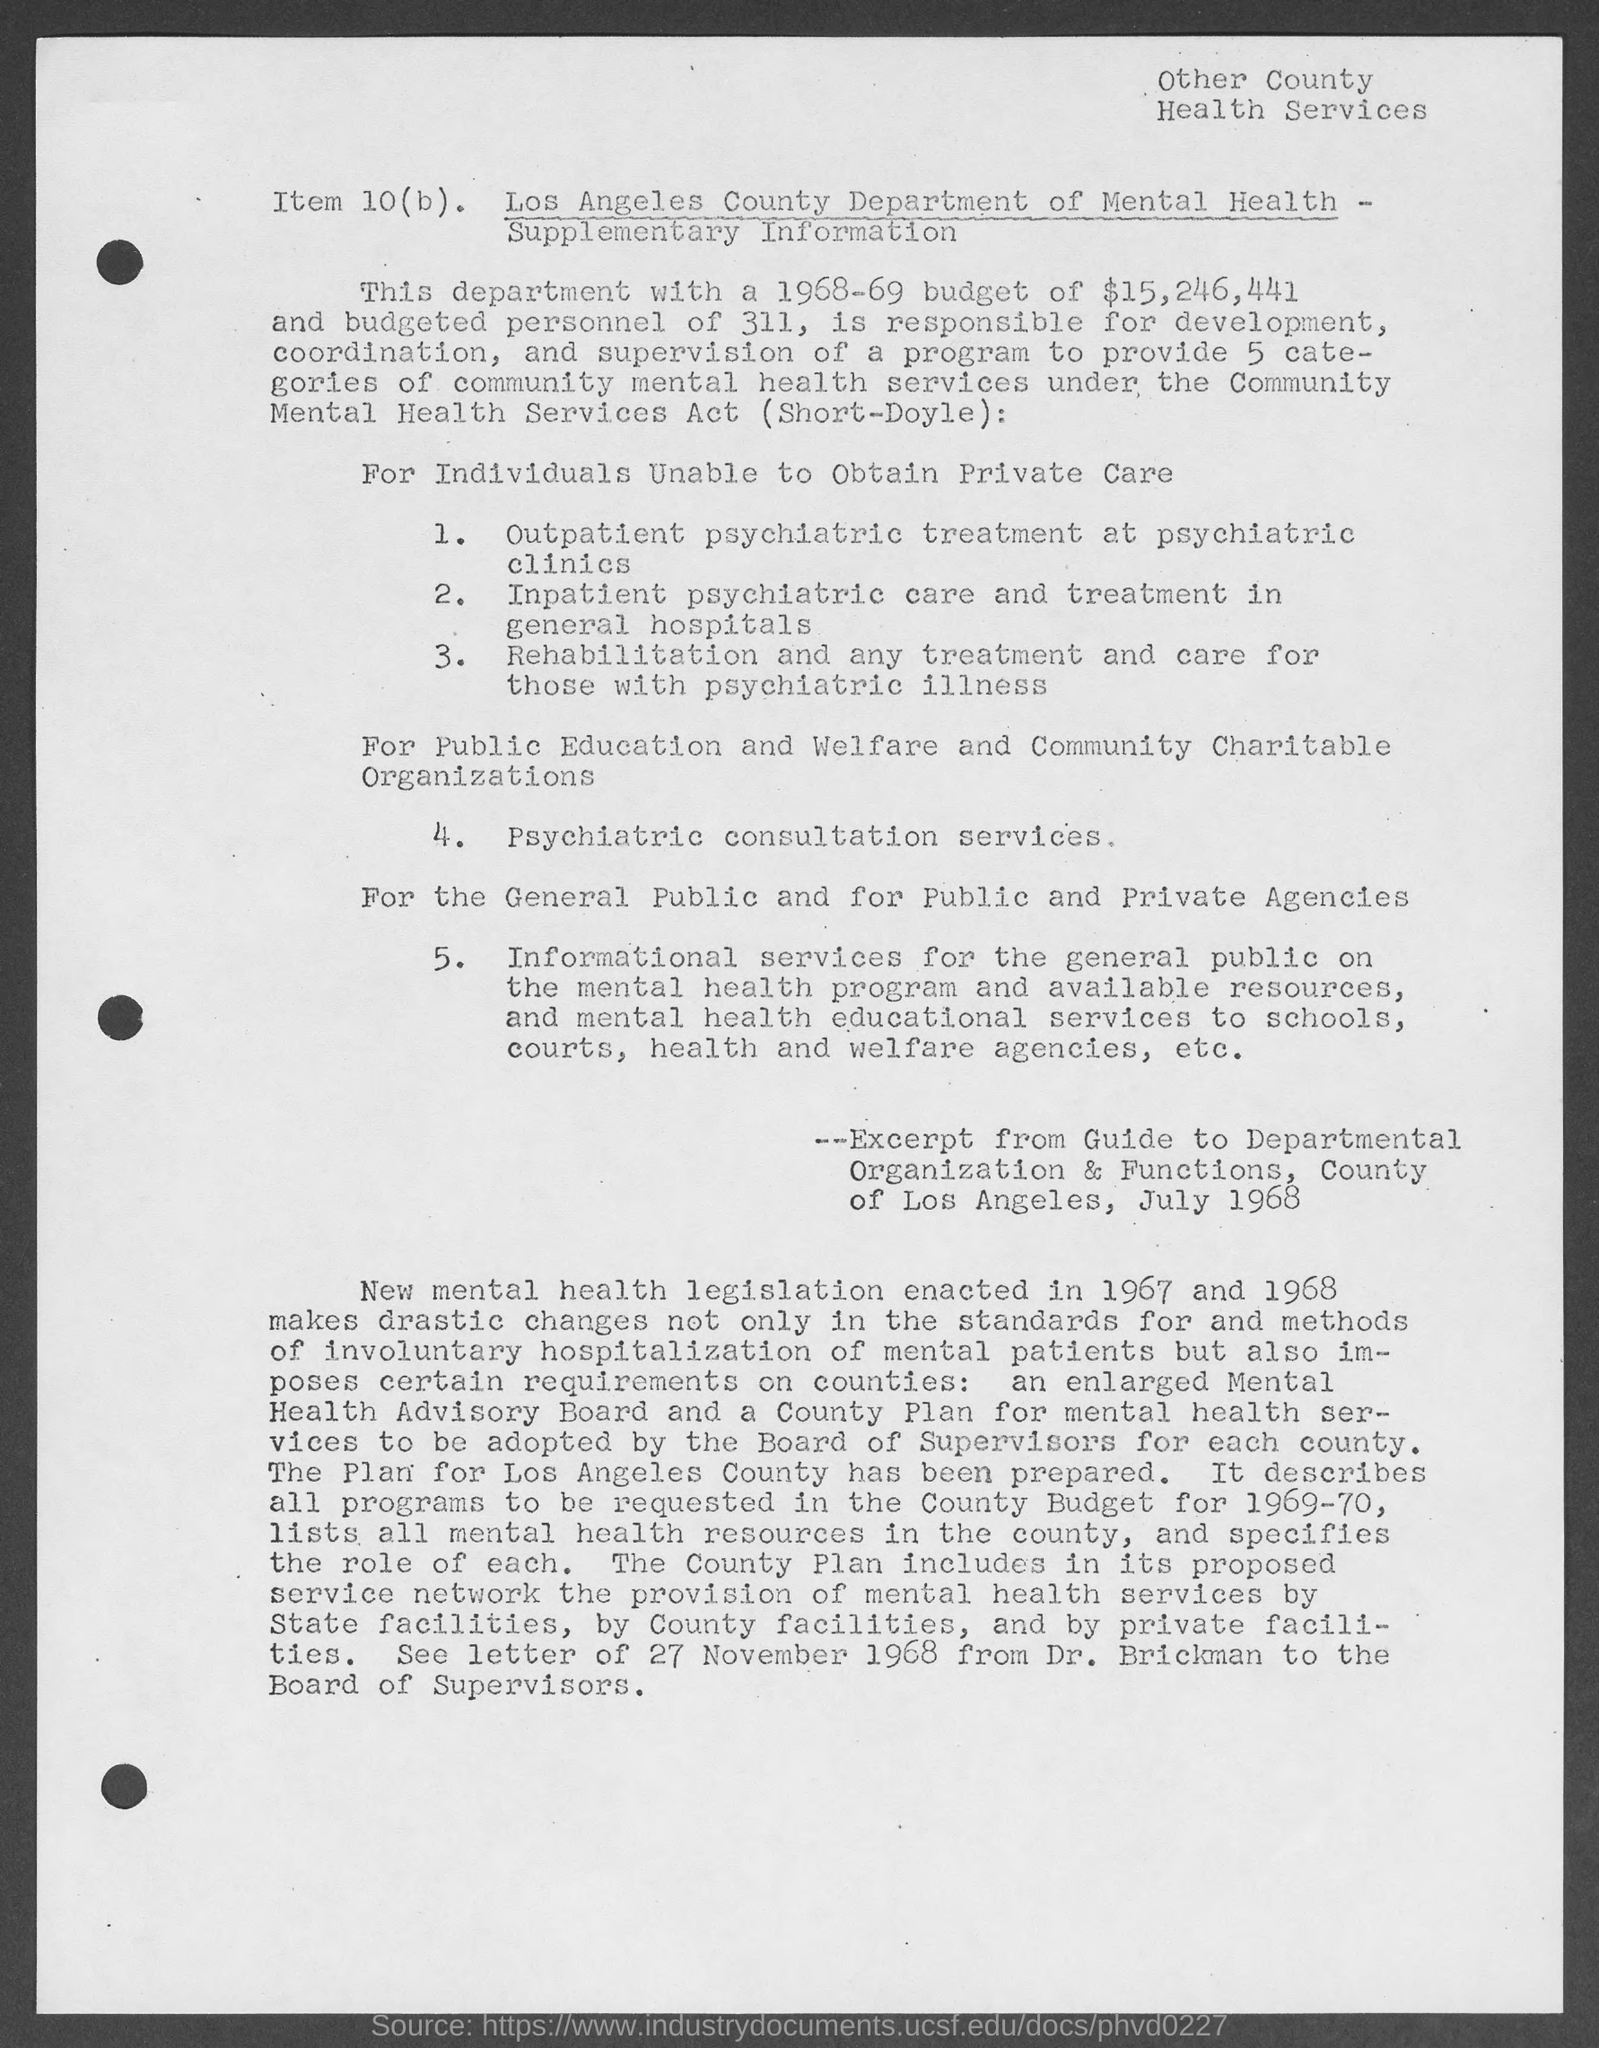What is the name of the Mental Health department?
Your answer should be very brief. Los Angeles County Department of Mental Health. What is the fourth point mentioned in the points For Individuals Unable to Obtain Private Care?
Offer a very short reply. Psychiatric consultation services. What is written on the top-right of the document?
Give a very brief answer. Other County Health Services. What is the budget of the department?
Offer a very short reply. $15,246,441. 